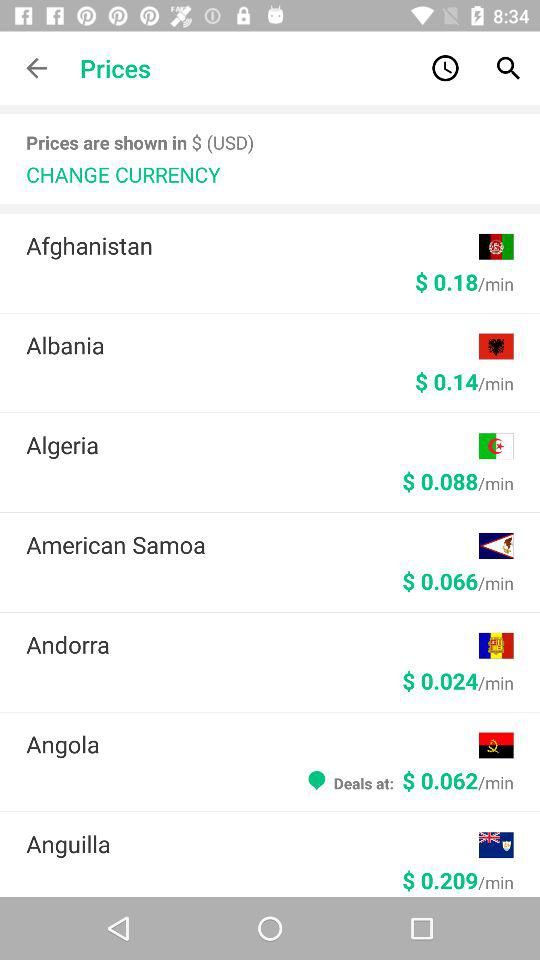What is the per minute cost in Albania? The per minute cost in Albania is $ 0.14. 